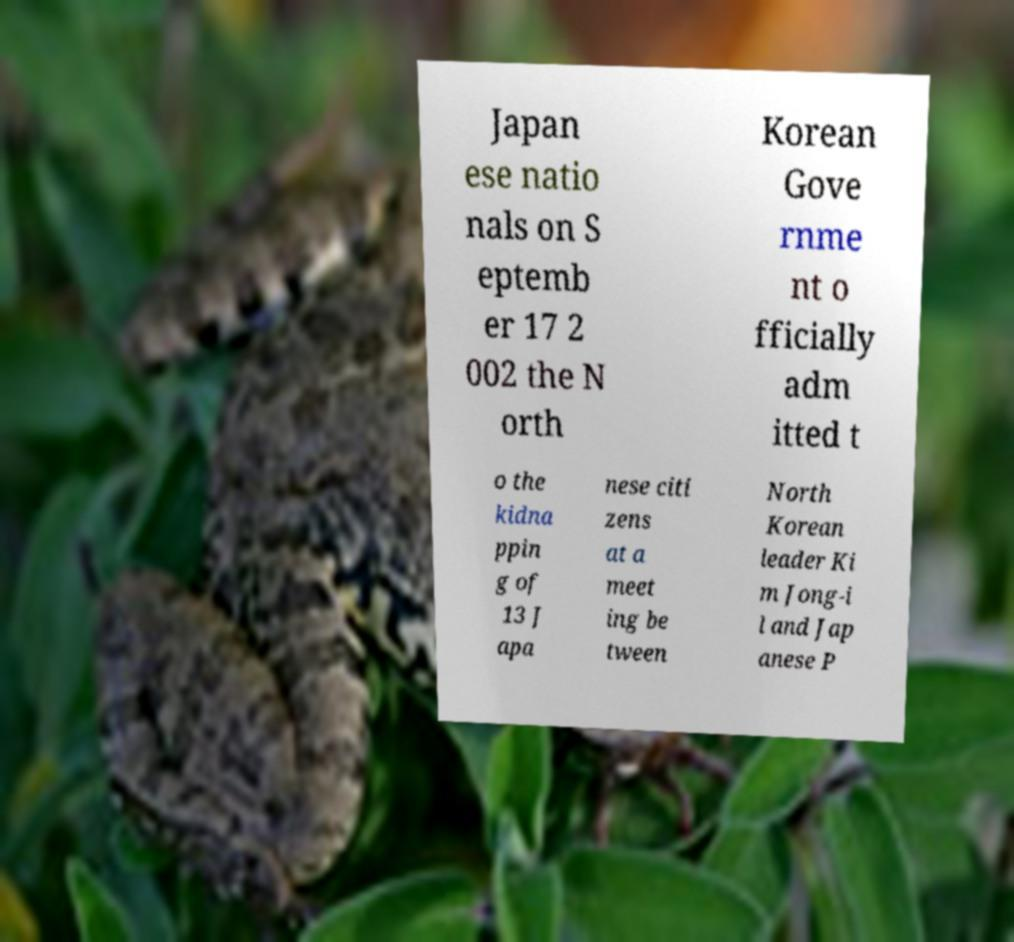Could you extract and type out the text from this image? Japan ese natio nals on S eptemb er 17 2 002 the N orth Korean Gove rnme nt o fficially adm itted t o the kidna ppin g of 13 J apa nese citi zens at a meet ing be tween North Korean leader Ki m Jong-i l and Jap anese P 